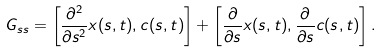<formula> <loc_0><loc_0><loc_500><loc_500>G _ { s s } = \left [ \frac { \partial ^ { 2 } } { \partial s ^ { 2 } } x ( s , t ) , c ( s , t ) \right ] + \left [ \frac { \partial } { \partial s } x ( s , t ) , \frac { \partial } { \partial s } c ( s , t ) \right ] .</formula> 